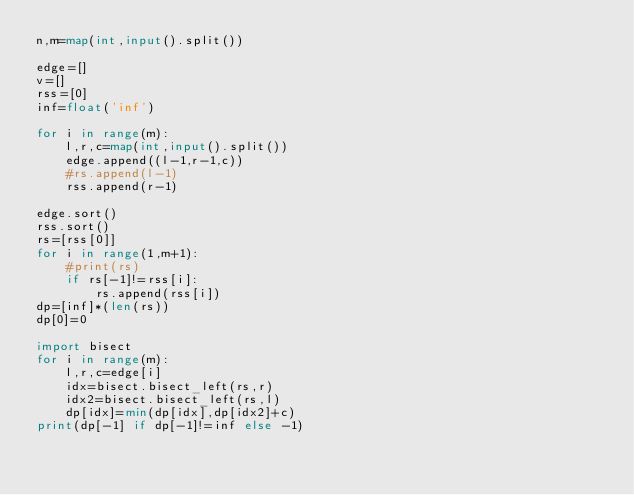<code> <loc_0><loc_0><loc_500><loc_500><_Python_>n,m=map(int,input().split())

edge=[]
v=[]
rss=[0]
inf=float('inf')

for i in range(m):
    l,r,c=map(int,input().split())
    edge.append((l-1,r-1,c))
    #rs.append(l-1)
    rss.append(r-1)

edge.sort()
rss.sort()
rs=[rss[0]]
for i in range(1,m+1):
    #print(rs)
    if rs[-1]!=rss[i]:
        rs.append(rss[i])
dp=[inf]*(len(rs))
dp[0]=0

import bisect
for i in range(m):
    l,r,c=edge[i]
    idx=bisect.bisect_left(rs,r)
    idx2=bisect.bisect_left(rs,l)
    dp[idx]=min(dp[idx],dp[idx2]+c)
print(dp[-1] if dp[-1]!=inf else -1)
</code> 